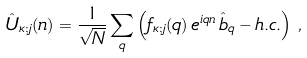<formula> <loc_0><loc_0><loc_500><loc_500>\hat { U } _ { \kappa ; j } ( n ) = \frac { 1 } { \sqrt { N } } \sum _ { q } \left ( f _ { \kappa ; j } ( q ) \, e ^ { i q n } \, \hat { b } _ { q } - h . c . \right ) \, ,</formula> 